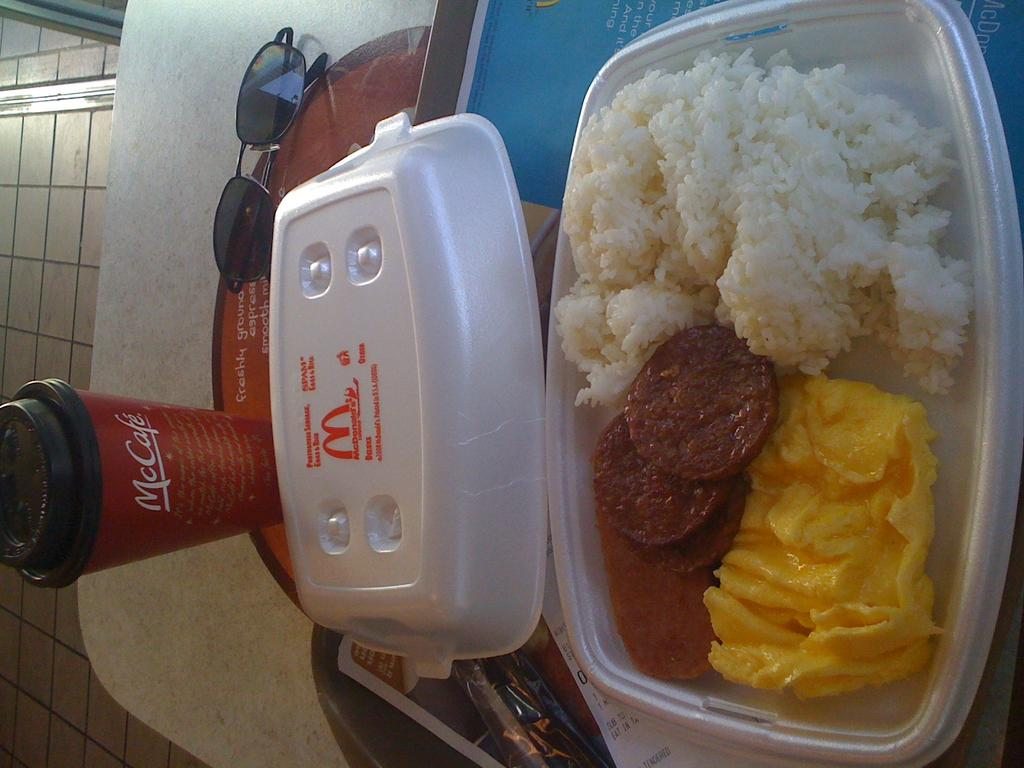What is on the right side of the image? There is food in a plastic plate on the right side of the image. What is on the left side of the image? There is a glass on the left side of the image. What can be seen at the top of the image? There are spectacles at the top of the image. What type of soup is being served in the image? There is no soup present in the image; it features food on a plastic plate and a glass. What shape is the rest area in the image? There is no rest area present in the image. 